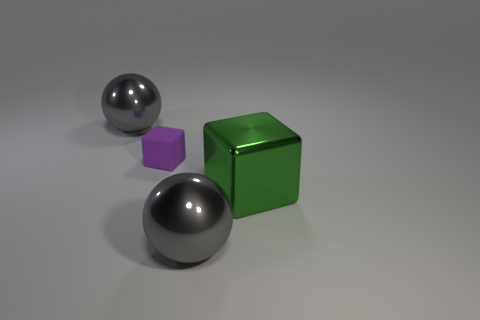What material is the other large thing that is the same shape as the matte object?
Your answer should be compact. Metal. There is a gray thing that is in front of the tiny thing; what material is it?
Make the answer very short. Metal. How many shiny balls are the same size as the green metal thing?
Give a very brief answer. 2. There is a gray metallic ball that is behind the green metallic object; is its size the same as the green cube?
Make the answer very short. Yes. There is a big object that is in front of the small purple cube and to the left of the green object; what is its shape?
Make the answer very short. Sphere. There is a tiny purple thing; are there any big green shiny objects on the left side of it?
Keep it short and to the point. No. Is there anything else that has the same shape as the tiny rubber thing?
Make the answer very short. Yes. Is the green object the same shape as the purple matte thing?
Offer a terse response. Yes. Are there an equal number of big green objects on the right side of the rubber cube and objects that are to the right of the large block?
Offer a terse response. No. How many other things are the same material as the small purple thing?
Ensure brevity in your answer.  0. 